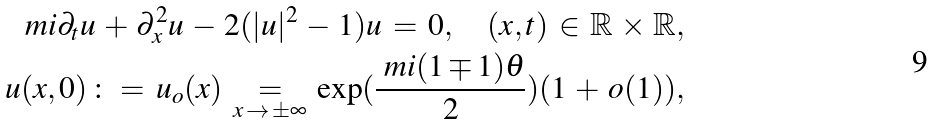<formula> <loc_0><loc_0><loc_500><loc_500>\ m i \partial _ { t } u \, + \, \partial _ { x } ^ { 2 } u \, - \, 2 ( | u | ^ { 2 } \, - \, 1 ) u \, = \, 0 , \quad ( x , t ) \, \in \, \mathbb { R } \, \times \, \mathbb { R } , \\ u ( x , 0 ) \, \colon = \, u _ { o } ( x ) \, \underset { x \, \to \, \pm \infty } { = } \, \exp ( \frac { \ m i ( 1 \mp 1 ) \theta } { 2 } ) ( 1 \, + \, o ( 1 ) ) ,</formula> 